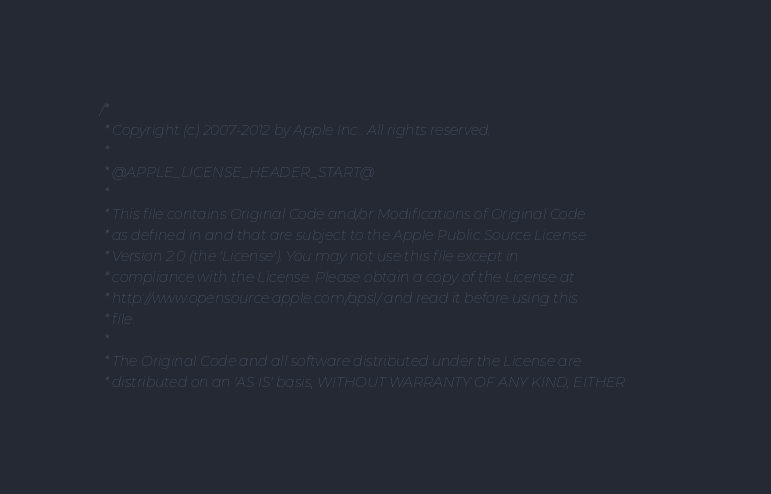<code> <loc_0><loc_0><loc_500><loc_500><_C_>/*
 * Copyright (c) 2007-2012 by Apple Inc.. All rights reserved.
 *
 * @APPLE_LICENSE_HEADER_START@
 * 
 * This file contains Original Code and/or Modifications of Original Code
 * as defined in and that are subject to the Apple Public Source License
 * Version 2.0 (the 'License'). You may not use this file except in
 * compliance with the License. Please obtain a copy of the License at
 * http://www.opensource.apple.com/apsl/ and read it before using this
 * file.
 * 
 * The Original Code and all software distributed under the License are
 * distributed on an 'AS IS' basis, WITHOUT WARRANTY OF ANY KIND, EITHER</code> 